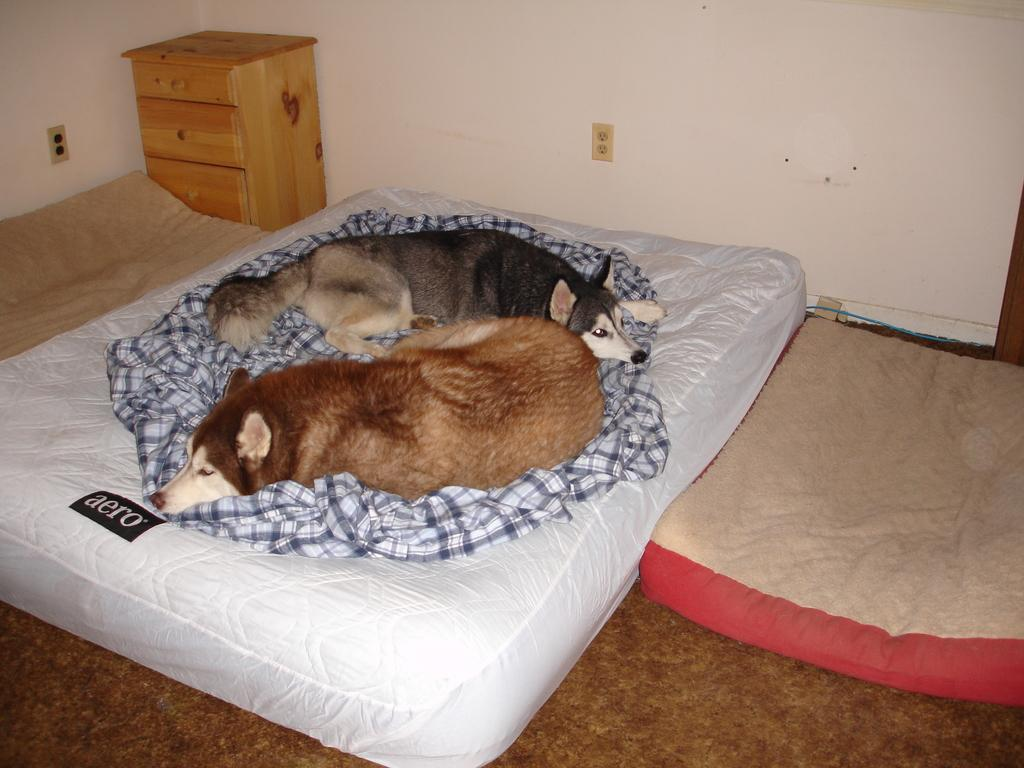How many dogs are in the image? There are two dogs in the image. What are the dogs lying on? The dogs are lying on a cloth. Where is the cloth located? The cloth is on a bed. What is the position of the bed in the image? The bed is on the floor. How many other small beds are in the image? There are two other small beds in the image. What can be seen in the background of the image? There is a cupboard and sockets on the wall in the background of the image. What type of office equipment can be seen on the dogs in the image? There is no office equipment present in the image, as it features two dogs lying on a cloth on a bed. 